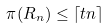Convert formula to latex. <formula><loc_0><loc_0><loc_500><loc_500>\pi ( R _ { n } ) \leq \lceil t n \rceil</formula> 